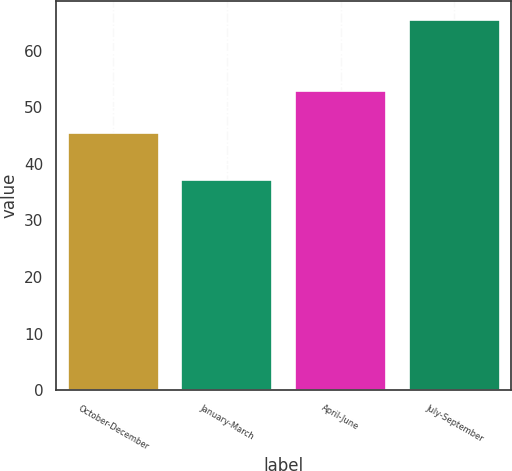Convert chart. <chart><loc_0><loc_0><loc_500><loc_500><bar_chart><fcel>October-December<fcel>January-March<fcel>April-June<fcel>July-September<nl><fcel>45.52<fcel>37.19<fcel>52.93<fcel>65.48<nl></chart> 